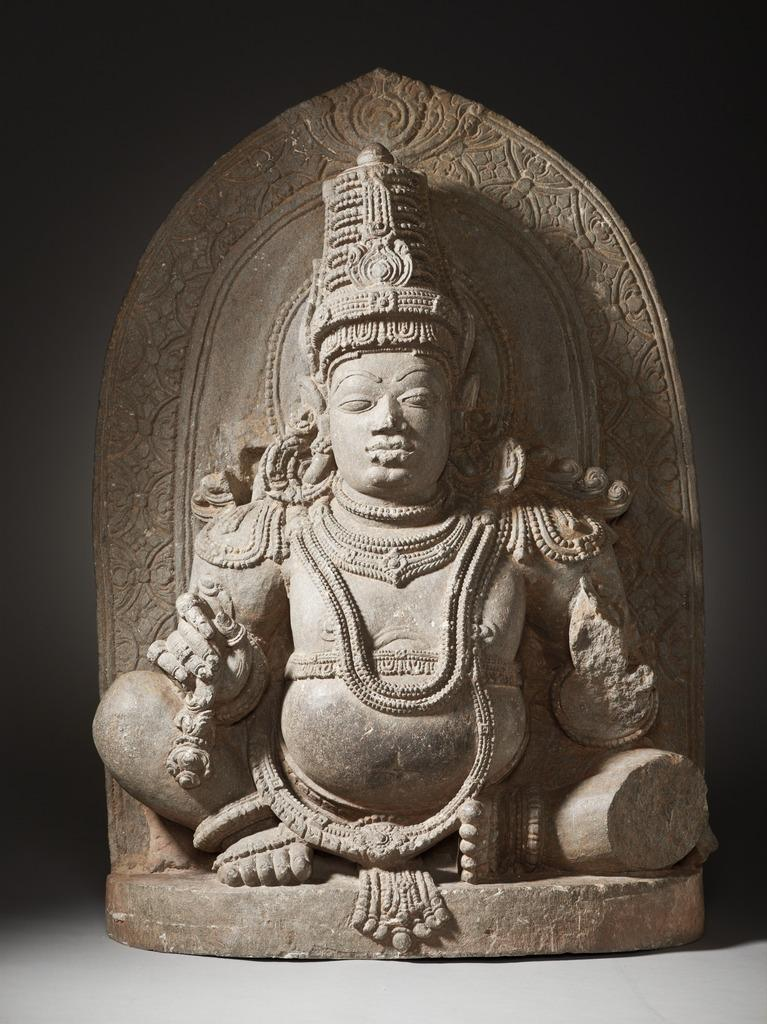What is the main subject of the image? There is a statue in the image. Can you describe the colors of the statue? The statue has grey and brown colors. What is the color of the background in the image? The background of the image is black. What type of canvas is being used to support the straw in the image? There is no canvas or straw present in the image; it features a statue with grey and brown colors against a black background. 